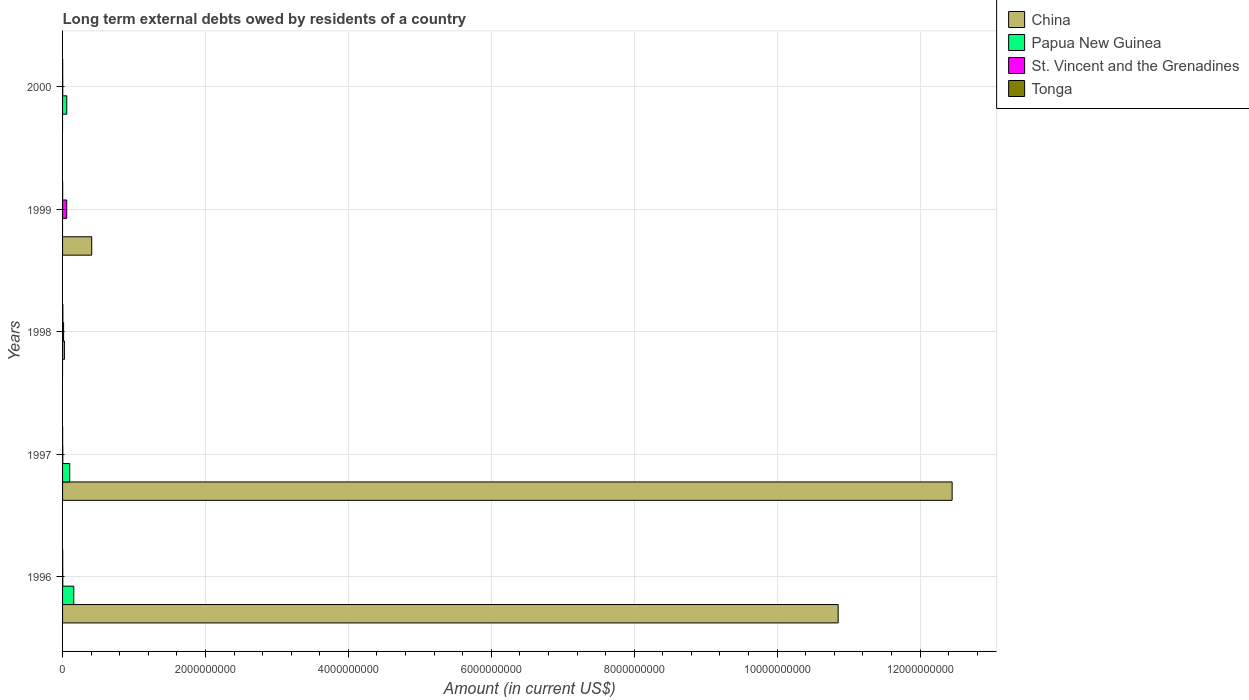Are the number of bars on each tick of the Y-axis equal?
Provide a short and direct response. No. How many bars are there on the 5th tick from the bottom?
Offer a very short reply. 3. What is the label of the 2nd group of bars from the top?
Ensure brevity in your answer.  1999. What is the amount of long-term external debts owed by residents in St. Vincent and the Grenadines in 1998?
Your answer should be compact. 1.44e+07. Across all years, what is the maximum amount of long-term external debts owed by residents in Papua New Guinea?
Give a very brief answer. 1.57e+08. Across all years, what is the minimum amount of long-term external debts owed by residents in St. Vincent and the Grenadines?
Your response must be concise. 2.42e+06. In which year was the amount of long-term external debts owed by residents in St. Vincent and the Grenadines maximum?
Provide a short and direct response. 1999. What is the total amount of long-term external debts owed by residents in Papua New Guinea in the graph?
Make the answer very short. 3.42e+08. What is the difference between the amount of long-term external debts owed by residents in Tonga in 1999 and that in 2000?
Make the answer very short. -5.38e+05. What is the difference between the amount of long-term external debts owed by residents in Tonga in 1996 and the amount of long-term external debts owed by residents in Papua New Guinea in 1999?
Give a very brief answer. 1.86e+06. What is the average amount of long-term external debts owed by residents in China per year?
Offer a very short reply. 4.74e+09. In the year 1996, what is the difference between the amount of long-term external debts owed by residents in Papua New Guinea and amount of long-term external debts owed by residents in Tonga?
Your answer should be compact. 1.55e+08. In how many years, is the amount of long-term external debts owed by residents in St. Vincent and the Grenadines greater than 1200000000 US$?
Provide a short and direct response. 0. What is the ratio of the amount of long-term external debts owed by residents in Tonga in 1997 to that in 1999?
Offer a very short reply. 0.67. Is the amount of long-term external debts owed by residents in St. Vincent and the Grenadines in 1998 less than that in 2000?
Provide a short and direct response. No. What is the difference between the highest and the second highest amount of long-term external debts owed by residents in St. Vincent and the Grenadines?
Provide a succinct answer. 4.38e+07. What is the difference between the highest and the lowest amount of long-term external debts owed by residents in Tonga?
Ensure brevity in your answer.  3.48e+06. In how many years, is the amount of long-term external debts owed by residents in St. Vincent and the Grenadines greater than the average amount of long-term external debts owed by residents in St. Vincent and the Grenadines taken over all years?
Ensure brevity in your answer.  1. Is it the case that in every year, the sum of the amount of long-term external debts owed by residents in St. Vincent and the Grenadines and amount of long-term external debts owed by residents in Tonga is greater than the sum of amount of long-term external debts owed by residents in China and amount of long-term external debts owed by residents in Papua New Guinea?
Make the answer very short. No. How many bars are there?
Keep it short and to the point. 17. What is the difference between two consecutive major ticks on the X-axis?
Provide a succinct answer. 2.00e+09. Are the values on the major ticks of X-axis written in scientific E-notation?
Offer a very short reply. No. Does the graph contain any zero values?
Ensure brevity in your answer.  Yes. How many legend labels are there?
Offer a terse response. 4. How are the legend labels stacked?
Your answer should be compact. Vertical. What is the title of the graph?
Ensure brevity in your answer.  Long term external debts owed by residents of a country. What is the Amount (in current US$) in China in 1996?
Offer a terse response. 1.09e+1. What is the Amount (in current US$) of Papua New Guinea in 1996?
Your response must be concise. 1.57e+08. What is the Amount (in current US$) in St. Vincent and the Grenadines in 1996?
Your answer should be very brief. 3.09e+06. What is the Amount (in current US$) of Tonga in 1996?
Your answer should be very brief. 1.86e+06. What is the Amount (in current US$) of China in 1997?
Offer a very short reply. 1.24e+1. What is the Amount (in current US$) of Papua New Guinea in 1997?
Your response must be concise. 1.00e+08. What is the Amount (in current US$) in St. Vincent and the Grenadines in 1997?
Give a very brief answer. 3.04e+06. What is the Amount (in current US$) in Tonga in 1997?
Make the answer very short. 8.12e+05. What is the Amount (in current US$) in China in 1998?
Keep it short and to the point. 0. What is the Amount (in current US$) of Papua New Guinea in 1998?
Make the answer very short. 2.59e+07. What is the Amount (in current US$) of St. Vincent and the Grenadines in 1998?
Ensure brevity in your answer.  1.44e+07. What is the Amount (in current US$) in Tonga in 1998?
Ensure brevity in your answer.  4.29e+06. What is the Amount (in current US$) in China in 1999?
Offer a very short reply. 4.08e+08. What is the Amount (in current US$) in Papua New Guinea in 1999?
Provide a succinct answer. 0. What is the Amount (in current US$) of St. Vincent and the Grenadines in 1999?
Your response must be concise. 5.81e+07. What is the Amount (in current US$) in Tonga in 1999?
Your answer should be very brief. 1.22e+06. What is the Amount (in current US$) of China in 2000?
Your response must be concise. 0. What is the Amount (in current US$) in Papua New Guinea in 2000?
Give a very brief answer. 5.89e+07. What is the Amount (in current US$) of St. Vincent and the Grenadines in 2000?
Your response must be concise. 2.42e+06. What is the Amount (in current US$) in Tonga in 2000?
Provide a short and direct response. 1.76e+06. Across all years, what is the maximum Amount (in current US$) of China?
Ensure brevity in your answer.  1.24e+1. Across all years, what is the maximum Amount (in current US$) of Papua New Guinea?
Offer a terse response. 1.57e+08. Across all years, what is the maximum Amount (in current US$) in St. Vincent and the Grenadines?
Offer a very short reply. 5.81e+07. Across all years, what is the maximum Amount (in current US$) in Tonga?
Your response must be concise. 4.29e+06. Across all years, what is the minimum Amount (in current US$) of China?
Your response must be concise. 0. Across all years, what is the minimum Amount (in current US$) of Papua New Guinea?
Your answer should be very brief. 0. Across all years, what is the minimum Amount (in current US$) of St. Vincent and the Grenadines?
Give a very brief answer. 2.42e+06. Across all years, what is the minimum Amount (in current US$) of Tonga?
Provide a short and direct response. 8.12e+05. What is the total Amount (in current US$) of China in the graph?
Offer a very short reply. 2.37e+1. What is the total Amount (in current US$) in Papua New Guinea in the graph?
Keep it short and to the point. 3.42e+08. What is the total Amount (in current US$) of St. Vincent and the Grenadines in the graph?
Provide a succinct answer. 8.11e+07. What is the total Amount (in current US$) in Tonga in the graph?
Your response must be concise. 9.94e+06. What is the difference between the Amount (in current US$) in China in 1996 and that in 1997?
Keep it short and to the point. -1.60e+09. What is the difference between the Amount (in current US$) in Papua New Guinea in 1996 and that in 1997?
Keep it short and to the point. 5.67e+07. What is the difference between the Amount (in current US$) of St. Vincent and the Grenadines in 1996 and that in 1997?
Ensure brevity in your answer.  5.10e+04. What is the difference between the Amount (in current US$) of Tonga in 1996 and that in 1997?
Provide a short and direct response. 1.05e+06. What is the difference between the Amount (in current US$) in Papua New Guinea in 1996 and that in 1998?
Provide a succinct answer. 1.31e+08. What is the difference between the Amount (in current US$) in St. Vincent and the Grenadines in 1996 and that in 1998?
Your response must be concise. -1.13e+07. What is the difference between the Amount (in current US$) of Tonga in 1996 and that in 1998?
Keep it short and to the point. -2.42e+06. What is the difference between the Amount (in current US$) of China in 1996 and that in 1999?
Make the answer very short. 1.04e+1. What is the difference between the Amount (in current US$) of St. Vincent and the Grenadines in 1996 and that in 1999?
Provide a short and direct response. -5.51e+07. What is the difference between the Amount (in current US$) in Tonga in 1996 and that in 1999?
Provide a succinct answer. 6.47e+05. What is the difference between the Amount (in current US$) of Papua New Guinea in 1996 and that in 2000?
Your answer should be very brief. 9.80e+07. What is the difference between the Amount (in current US$) in St. Vincent and the Grenadines in 1996 and that in 2000?
Offer a terse response. 6.73e+05. What is the difference between the Amount (in current US$) in Tonga in 1996 and that in 2000?
Your response must be concise. 1.09e+05. What is the difference between the Amount (in current US$) in Papua New Guinea in 1997 and that in 1998?
Make the answer very short. 7.43e+07. What is the difference between the Amount (in current US$) in St. Vincent and the Grenadines in 1997 and that in 1998?
Your answer should be compact. -1.14e+07. What is the difference between the Amount (in current US$) of Tonga in 1997 and that in 1998?
Give a very brief answer. -3.48e+06. What is the difference between the Amount (in current US$) of China in 1997 and that in 1999?
Ensure brevity in your answer.  1.20e+1. What is the difference between the Amount (in current US$) in St. Vincent and the Grenadines in 1997 and that in 1999?
Ensure brevity in your answer.  -5.51e+07. What is the difference between the Amount (in current US$) in Tonga in 1997 and that in 1999?
Provide a succinct answer. -4.06e+05. What is the difference between the Amount (in current US$) of Papua New Guinea in 1997 and that in 2000?
Make the answer very short. 4.13e+07. What is the difference between the Amount (in current US$) of St. Vincent and the Grenadines in 1997 and that in 2000?
Keep it short and to the point. 6.22e+05. What is the difference between the Amount (in current US$) of Tonga in 1997 and that in 2000?
Keep it short and to the point. -9.44e+05. What is the difference between the Amount (in current US$) of St. Vincent and the Grenadines in 1998 and that in 1999?
Make the answer very short. -4.38e+07. What is the difference between the Amount (in current US$) of Tonga in 1998 and that in 1999?
Give a very brief answer. 3.07e+06. What is the difference between the Amount (in current US$) in Papua New Guinea in 1998 and that in 2000?
Offer a very short reply. -3.30e+07. What is the difference between the Amount (in current US$) in St. Vincent and the Grenadines in 1998 and that in 2000?
Make the answer very short. 1.20e+07. What is the difference between the Amount (in current US$) in Tonga in 1998 and that in 2000?
Make the answer very short. 2.53e+06. What is the difference between the Amount (in current US$) in St. Vincent and the Grenadines in 1999 and that in 2000?
Provide a short and direct response. 5.57e+07. What is the difference between the Amount (in current US$) of Tonga in 1999 and that in 2000?
Make the answer very short. -5.38e+05. What is the difference between the Amount (in current US$) in China in 1996 and the Amount (in current US$) in Papua New Guinea in 1997?
Your response must be concise. 1.08e+1. What is the difference between the Amount (in current US$) of China in 1996 and the Amount (in current US$) of St. Vincent and the Grenadines in 1997?
Your answer should be very brief. 1.09e+1. What is the difference between the Amount (in current US$) in China in 1996 and the Amount (in current US$) in Tonga in 1997?
Ensure brevity in your answer.  1.09e+1. What is the difference between the Amount (in current US$) of Papua New Guinea in 1996 and the Amount (in current US$) of St. Vincent and the Grenadines in 1997?
Provide a short and direct response. 1.54e+08. What is the difference between the Amount (in current US$) in Papua New Guinea in 1996 and the Amount (in current US$) in Tonga in 1997?
Your answer should be very brief. 1.56e+08. What is the difference between the Amount (in current US$) in St. Vincent and the Grenadines in 1996 and the Amount (in current US$) in Tonga in 1997?
Keep it short and to the point. 2.28e+06. What is the difference between the Amount (in current US$) in China in 1996 and the Amount (in current US$) in Papua New Guinea in 1998?
Provide a short and direct response. 1.08e+1. What is the difference between the Amount (in current US$) of China in 1996 and the Amount (in current US$) of St. Vincent and the Grenadines in 1998?
Your answer should be compact. 1.08e+1. What is the difference between the Amount (in current US$) in China in 1996 and the Amount (in current US$) in Tonga in 1998?
Make the answer very short. 1.08e+1. What is the difference between the Amount (in current US$) of Papua New Guinea in 1996 and the Amount (in current US$) of St. Vincent and the Grenadines in 1998?
Make the answer very short. 1.43e+08. What is the difference between the Amount (in current US$) of Papua New Guinea in 1996 and the Amount (in current US$) of Tonga in 1998?
Offer a terse response. 1.53e+08. What is the difference between the Amount (in current US$) in St. Vincent and the Grenadines in 1996 and the Amount (in current US$) in Tonga in 1998?
Keep it short and to the point. -1.20e+06. What is the difference between the Amount (in current US$) in China in 1996 and the Amount (in current US$) in St. Vincent and the Grenadines in 1999?
Offer a terse response. 1.08e+1. What is the difference between the Amount (in current US$) in China in 1996 and the Amount (in current US$) in Tonga in 1999?
Keep it short and to the point. 1.09e+1. What is the difference between the Amount (in current US$) of Papua New Guinea in 1996 and the Amount (in current US$) of St. Vincent and the Grenadines in 1999?
Give a very brief answer. 9.88e+07. What is the difference between the Amount (in current US$) in Papua New Guinea in 1996 and the Amount (in current US$) in Tonga in 1999?
Ensure brevity in your answer.  1.56e+08. What is the difference between the Amount (in current US$) of St. Vincent and the Grenadines in 1996 and the Amount (in current US$) of Tonga in 1999?
Your answer should be very brief. 1.87e+06. What is the difference between the Amount (in current US$) in China in 1996 and the Amount (in current US$) in Papua New Guinea in 2000?
Offer a very short reply. 1.08e+1. What is the difference between the Amount (in current US$) of China in 1996 and the Amount (in current US$) of St. Vincent and the Grenadines in 2000?
Offer a very short reply. 1.09e+1. What is the difference between the Amount (in current US$) in China in 1996 and the Amount (in current US$) in Tonga in 2000?
Provide a short and direct response. 1.09e+1. What is the difference between the Amount (in current US$) in Papua New Guinea in 1996 and the Amount (in current US$) in St. Vincent and the Grenadines in 2000?
Your answer should be compact. 1.54e+08. What is the difference between the Amount (in current US$) in Papua New Guinea in 1996 and the Amount (in current US$) in Tonga in 2000?
Provide a short and direct response. 1.55e+08. What is the difference between the Amount (in current US$) of St. Vincent and the Grenadines in 1996 and the Amount (in current US$) of Tonga in 2000?
Your response must be concise. 1.33e+06. What is the difference between the Amount (in current US$) of China in 1997 and the Amount (in current US$) of Papua New Guinea in 1998?
Offer a terse response. 1.24e+1. What is the difference between the Amount (in current US$) of China in 1997 and the Amount (in current US$) of St. Vincent and the Grenadines in 1998?
Offer a terse response. 1.24e+1. What is the difference between the Amount (in current US$) of China in 1997 and the Amount (in current US$) of Tonga in 1998?
Your answer should be compact. 1.24e+1. What is the difference between the Amount (in current US$) of Papua New Guinea in 1997 and the Amount (in current US$) of St. Vincent and the Grenadines in 1998?
Make the answer very short. 8.58e+07. What is the difference between the Amount (in current US$) in Papua New Guinea in 1997 and the Amount (in current US$) in Tonga in 1998?
Keep it short and to the point. 9.59e+07. What is the difference between the Amount (in current US$) in St. Vincent and the Grenadines in 1997 and the Amount (in current US$) in Tonga in 1998?
Your answer should be compact. -1.25e+06. What is the difference between the Amount (in current US$) in China in 1997 and the Amount (in current US$) in St. Vincent and the Grenadines in 1999?
Your answer should be very brief. 1.24e+1. What is the difference between the Amount (in current US$) of China in 1997 and the Amount (in current US$) of Tonga in 1999?
Ensure brevity in your answer.  1.24e+1. What is the difference between the Amount (in current US$) of Papua New Guinea in 1997 and the Amount (in current US$) of St. Vincent and the Grenadines in 1999?
Your response must be concise. 4.20e+07. What is the difference between the Amount (in current US$) in Papua New Guinea in 1997 and the Amount (in current US$) in Tonga in 1999?
Give a very brief answer. 9.90e+07. What is the difference between the Amount (in current US$) in St. Vincent and the Grenadines in 1997 and the Amount (in current US$) in Tonga in 1999?
Provide a short and direct response. 1.82e+06. What is the difference between the Amount (in current US$) of China in 1997 and the Amount (in current US$) of Papua New Guinea in 2000?
Keep it short and to the point. 1.24e+1. What is the difference between the Amount (in current US$) in China in 1997 and the Amount (in current US$) in St. Vincent and the Grenadines in 2000?
Offer a terse response. 1.24e+1. What is the difference between the Amount (in current US$) of China in 1997 and the Amount (in current US$) of Tonga in 2000?
Offer a very short reply. 1.24e+1. What is the difference between the Amount (in current US$) in Papua New Guinea in 1997 and the Amount (in current US$) in St. Vincent and the Grenadines in 2000?
Provide a succinct answer. 9.78e+07. What is the difference between the Amount (in current US$) of Papua New Guinea in 1997 and the Amount (in current US$) of Tonga in 2000?
Your answer should be compact. 9.84e+07. What is the difference between the Amount (in current US$) in St. Vincent and the Grenadines in 1997 and the Amount (in current US$) in Tonga in 2000?
Make the answer very short. 1.28e+06. What is the difference between the Amount (in current US$) of Papua New Guinea in 1998 and the Amount (in current US$) of St. Vincent and the Grenadines in 1999?
Ensure brevity in your answer.  -3.23e+07. What is the difference between the Amount (in current US$) of Papua New Guinea in 1998 and the Amount (in current US$) of Tonga in 1999?
Your answer should be very brief. 2.47e+07. What is the difference between the Amount (in current US$) in St. Vincent and the Grenadines in 1998 and the Amount (in current US$) in Tonga in 1999?
Make the answer very short. 1.32e+07. What is the difference between the Amount (in current US$) in Papua New Guinea in 1998 and the Amount (in current US$) in St. Vincent and the Grenadines in 2000?
Offer a terse response. 2.35e+07. What is the difference between the Amount (in current US$) in Papua New Guinea in 1998 and the Amount (in current US$) in Tonga in 2000?
Make the answer very short. 2.41e+07. What is the difference between the Amount (in current US$) in St. Vincent and the Grenadines in 1998 and the Amount (in current US$) in Tonga in 2000?
Offer a very short reply. 1.26e+07. What is the difference between the Amount (in current US$) of China in 1999 and the Amount (in current US$) of Papua New Guinea in 2000?
Keep it short and to the point. 3.49e+08. What is the difference between the Amount (in current US$) in China in 1999 and the Amount (in current US$) in St. Vincent and the Grenadines in 2000?
Provide a short and direct response. 4.06e+08. What is the difference between the Amount (in current US$) in China in 1999 and the Amount (in current US$) in Tonga in 2000?
Give a very brief answer. 4.06e+08. What is the difference between the Amount (in current US$) in St. Vincent and the Grenadines in 1999 and the Amount (in current US$) in Tonga in 2000?
Provide a short and direct response. 5.64e+07. What is the average Amount (in current US$) of China per year?
Ensure brevity in your answer.  4.74e+09. What is the average Amount (in current US$) of Papua New Guinea per year?
Provide a short and direct response. 6.84e+07. What is the average Amount (in current US$) of St. Vincent and the Grenadines per year?
Your response must be concise. 1.62e+07. What is the average Amount (in current US$) of Tonga per year?
Your answer should be compact. 1.99e+06. In the year 1996, what is the difference between the Amount (in current US$) of China and Amount (in current US$) of Papua New Guinea?
Give a very brief answer. 1.07e+1. In the year 1996, what is the difference between the Amount (in current US$) in China and Amount (in current US$) in St. Vincent and the Grenadines?
Your response must be concise. 1.09e+1. In the year 1996, what is the difference between the Amount (in current US$) in China and Amount (in current US$) in Tonga?
Your answer should be very brief. 1.09e+1. In the year 1996, what is the difference between the Amount (in current US$) in Papua New Guinea and Amount (in current US$) in St. Vincent and the Grenadines?
Offer a very short reply. 1.54e+08. In the year 1996, what is the difference between the Amount (in current US$) in Papua New Guinea and Amount (in current US$) in Tonga?
Provide a short and direct response. 1.55e+08. In the year 1996, what is the difference between the Amount (in current US$) of St. Vincent and the Grenadines and Amount (in current US$) of Tonga?
Keep it short and to the point. 1.22e+06. In the year 1997, what is the difference between the Amount (in current US$) in China and Amount (in current US$) in Papua New Guinea?
Provide a succinct answer. 1.23e+1. In the year 1997, what is the difference between the Amount (in current US$) in China and Amount (in current US$) in St. Vincent and the Grenadines?
Make the answer very short. 1.24e+1. In the year 1997, what is the difference between the Amount (in current US$) of China and Amount (in current US$) of Tonga?
Keep it short and to the point. 1.24e+1. In the year 1997, what is the difference between the Amount (in current US$) in Papua New Guinea and Amount (in current US$) in St. Vincent and the Grenadines?
Offer a very short reply. 9.71e+07. In the year 1997, what is the difference between the Amount (in current US$) in Papua New Guinea and Amount (in current US$) in Tonga?
Your answer should be very brief. 9.94e+07. In the year 1997, what is the difference between the Amount (in current US$) in St. Vincent and the Grenadines and Amount (in current US$) in Tonga?
Your answer should be compact. 2.23e+06. In the year 1998, what is the difference between the Amount (in current US$) of Papua New Guinea and Amount (in current US$) of St. Vincent and the Grenadines?
Your answer should be compact. 1.15e+07. In the year 1998, what is the difference between the Amount (in current US$) in Papua New Guinea and Amount (in current US$) in Tonga?
Your answer should be compact. 2.16e+07. In the year 1998, what is the difference between the Amount (in current US$) of St. Vincent and the Grenadines and Amount (in current US$) of Tonga?
Ensure brevity in your answer.  1.01e+07. In the year 1999, what is the difference between the Amount (in current US$) of China and Amount (in current US$) of St. Vincent and the Grenadines?
Give a very brief answer. 3.50e+08. In the year 1999, what is the difference between the Amount (in current US$) in China and Amount (in current US$) in Tonga?
Provide a succinct answer. 4.07e+08. In the year 1999, what is the difference between the Amount (in current US$) of St. Vincent and the Grenadines and Amount (in current US$) of Tonga?
Keep it short and to the point. 5.69e+07. In the year 2000, what is the difference between the Amount (in current US$) in Papua New Guinea and Amount (in current US$) in St. Vincent and the Grenadines?
Keep it short and to the point. 5.64e+07. In the year 2000, what is the difference between the Amount (in current US$) in Papua New Guinea and Amount (in current US$) in Tonga?
Give a very brief answer. 5.71e+07. In the year 2000, what is the difference between the Amount (in current US$) of St. Vincent and the Grenadines and Amount (in current US$) of Tonga?
Keep it short and to the point. 6.61e+05. What is the ratio of the Amount (in current US$) in China in 1996 to that in 1997?
Provide a succinct answer. 0.87. What is the ratio of the Amount (in current US$) of Papua New Guinea in 1996 to that in 1997?
Ensure brevity in your answer.  1.57. What is the ratio of the Amount (in current US$) of St. Vincent and the Grenadines in 1996 to that in 1997?
Provide a succinct answer. 1.02. What is the ratio of the Amount (in current US$) of Tonga in 1996 to that in 1997?
Offer a very short reply. 2.3. What is the ratio of the Amount (in current US$) in Papua New Guinea in 1996 to that in 1998?
Make the answer very short. 6.07. What is the ratio of the Amount (in current US$) of St. Vincent and the Grenadines in 1996 to that in 1998?
Provide a succinct answer. 0.21. What is the ratio of the Amount (in current US$) in Tonga in 1996 to that in 1998?
Make the answer very short. 0.43. What is the ratio of the Amount (in current US$) of China in 1996 to that in 1999?
Ensure brevity in your answer.  26.61. What is the ratio of the Amount (in current US$) of St. Vincent and the Grenadines in 1996 to that in 1999?
Make the answer very short. 0.05. What is the ratio of the Amount (in current US$) of Tonga in 1996 to that in 1999?
Make the answer very short. 1.53. What is the ratio of the Amount (in current US$) in Papua New Guinea in 1996 to that in 2000?
Offer a terse response. 2.67. What is the ratio of the Amount (in current US$) of St. Vincent and the Grenadines in 1996 to that in 2000?
Your answer should be compact. 1.28. What is the ratio of the Amount (in current US$) of Tonga in 1996 to that in 2000?
Your response must be concise. 1.06. What is the ratio of the Amount (in current US$) in Papua New Guinea in 1997 to that in 1998?
Give a very brief answer. 3.87. What is the ratio of the Amount (in current US$) of St. Vincent and the Grenadines in 1997 to that in 1998?
Keep it short and to the point. 0.21. What is the ratio of the Amount (in current US$) in Tonga in 1997 to that in 1998?
Give a very brief answer. 0.19. What is the ratio of the Amount (in current US$) of China in 1997 to that in 1999?
Provide a succinct answer. 30.52. What is the ratio of the Amount (in current US$) of St. Vincent and the Grenadines in 1997 to that in 1999?
Your response must be concise. 0.05. What is the ratio of the Amount (in current US$) in Tonga in 1997 to that in 1999?
Make the answer very short. 0.67. What is the ratio of the Amount (in current US$) of Papua New Guinea in 1997 to that in 2000?
Offer a very short reply. 1.7. What is the ratio of the Amount (in current US$) in St. Vincent and the Grenadines in 1997 to that in 2000?
Offer a terse response. 1.26. What is the ratio of the Amount (in current US$) of Tonga in 1997 to that in 2000?
Provide a succinct answer. 0.46. What is the ratio of the Amount (in current US$) of St. Vincent and the Grenadines in 1998 to that in 1999?
Ensure brevity in your answer.  0.25. What is the ratio of the Amount (in current US$) of Tonga in 1998 to that in 1999?
Ensure brevity in your answer.  3.52. What is the ratio of the Amount (in current US$) in Papua New Guinea in 1998 to that in 2000?
Your answer should be compact. 0.44. What is the ratio of the Amount (in current US$) of St. Vincent and the Grenadines in 1998 to that in 2000?
Ensure brevity in your answer.  5.95. What is the ratio of the Amount (in current US$) in Tonga in 1998 to that in 2000?
Your answer should be very brief. 2.44. What is the ratio of the Amount (in current US$) of St. Vincent and the Grenadines in 1999 to that in 2000?
Offer a terse response. 24.06. What is the ratio of the Amount (in current US$) in Tonga in 1999 to that in 2000?
Keep it short and to the point. 0.69. What is the difference between the highest and the second highest Amount (in current US$) in China?
Provide a succinct answer. 1.60e+09. What is the difference between the highest and the second highest Amount (in current US$) of Papua New Guinea?
Your answer should be very brief. 5.67e+07. What is the difference between the highest and the second highest Amount (in current US$) of St. Vincent and the Grenadines?
Offer a terse response. 4.38e+07. What is the difference between the highest and the second highest Amount (in current US$) in Tonga?
Ensure brevity in your answer.  2.42e+06. What is the difference between the highest and the lowest Amount (in current US$) in China?
Make the answer very short. 1.24e+1. What is the difference between the highest and the lowest Amount (in current US$) of Papua New Guinea?
Your answer should be compact. 1.57e+08. What is the difference between the highest and the lowest Amount (in current US$) of St. Vincent and the Grenadines?
Your answer should be very brief. 5.57e+07. What is the difference between the highest and the lowest Amount (in current US$) in Tonga?
Your answer should be very brief. 3.48e+06. 